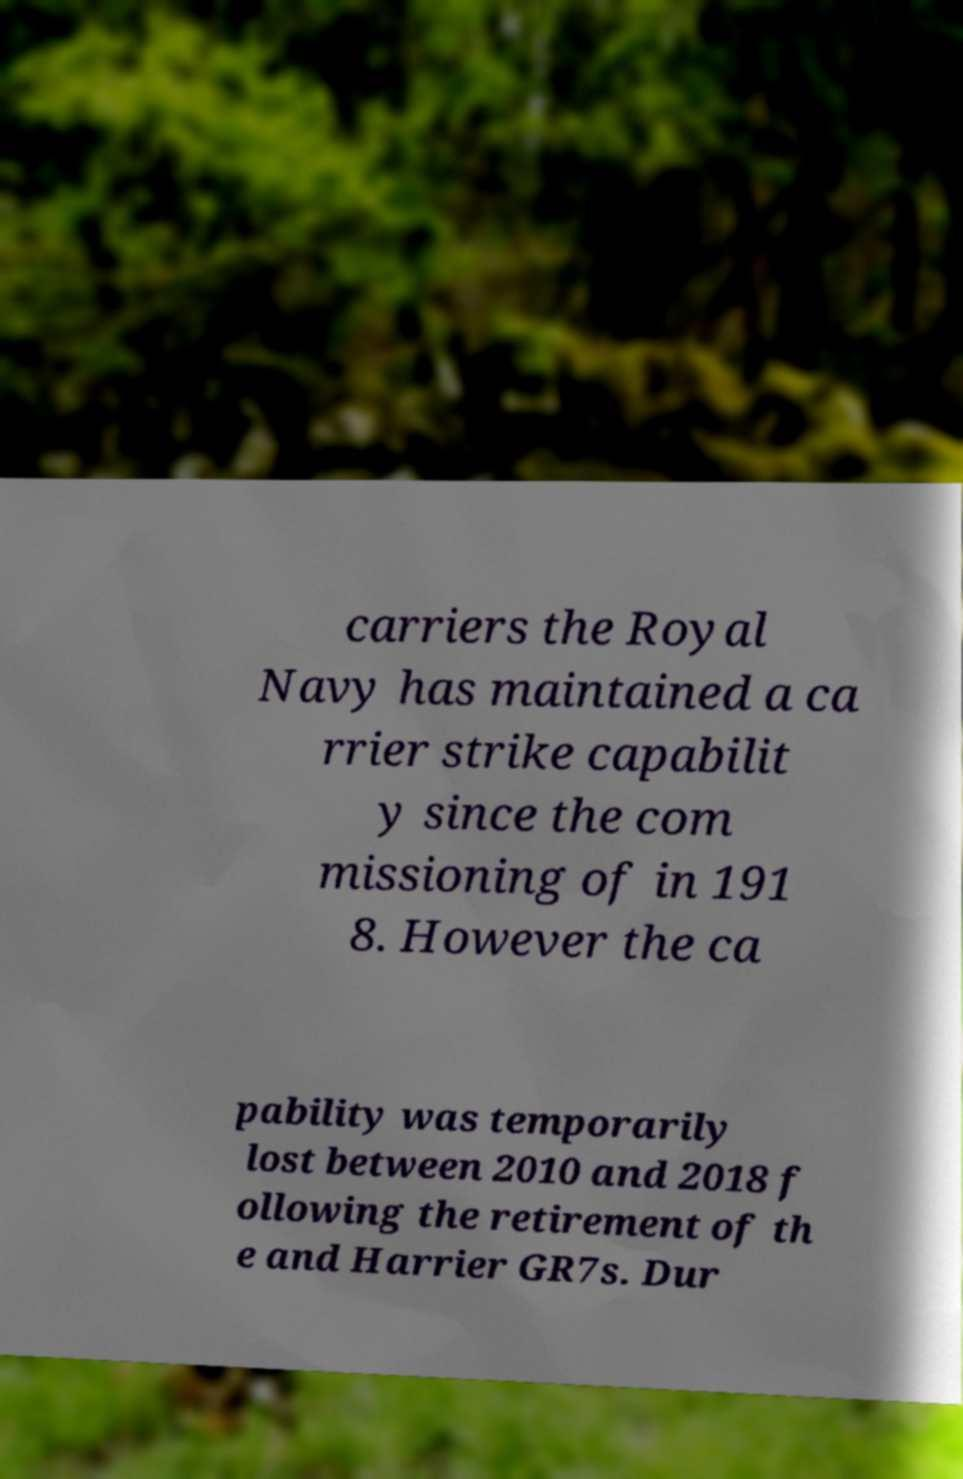There's text embedded in this image that I need extracted. Can you transcribe it verbatim? carriers the Royal Navy has maintained a ca rrier strike capabilit y since the com missioning of in 191 8. However the ca pability was temporarily lost between 2010 and 2018 f ollowing the retirement of th e and Harrier GR7s. Dur 